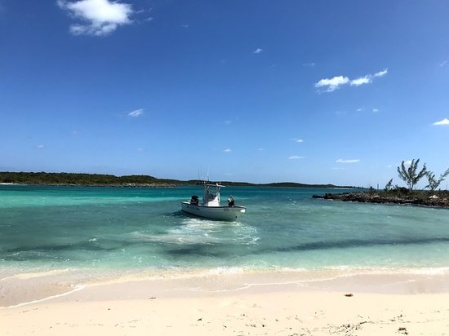Describe the island in the background. Could there be anything of interest there? The island in the background is a serene and lush piece of land, rich with trees and bushes, indicating a dense vegetation cover. It appears to be uninhabited, offering an untouched and natural environment. Such an island could be of great interest to nature enthusiasts, adventurers, or botanists looking to study regional flora and fauna. Hidden among the greenery might be unique plant species, bird nests, and other wildlife habitats. Its unspoiled beauty makes it a perfect spot for a secluded picnic, an adventurous exploration, or even a scientific expedition to study its ecosystem. What kind of stories might one weave around this island? One might imagine a mystical story where the island serves as a hidden refuge for ancient treasures, guarded by nature spirits that protect its secrets. Adventurers could embark on a quest, solving riddles and overcoming natural challenges to uncover a legendary pirate’s cache of gold and jewels. Alternatively, it could be a sanctuary where a castaway discovers rare plants with extraordinary medicinal properties, leading to a thrilling tale of discovery and survival against all odds. Or perhaps, it's the secret hideout of a reclusive writer who found inspiration in the island's serene beauty and wrote novels that changed the literary world. 